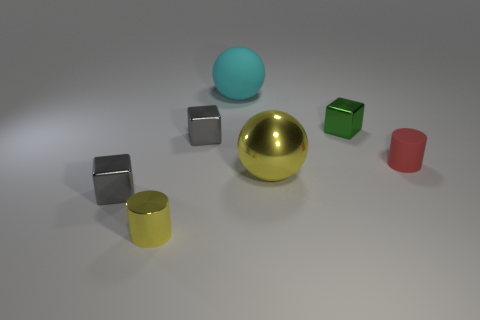Subtract all blue blocks. Subtract all gray balls. How many blocks are left? 3 Add 2 gray objects. How many objects exist? 9 Subtract all cylinders. How many objects are left? 5 Subtract all green cylinders. Subtract all yellow metal spheres. How many objects are left? 6 Add 6 tiny matte things. How many tiny matte things are left? 7 Add 1 big cyan blocks. How many big cyan blocks exist? 1 Subtract 0 red spheres. How many objects are left? 7 